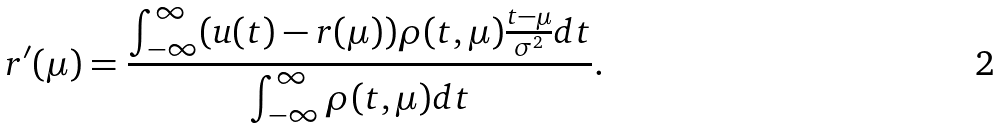<formula> <loc_0><loc_0><loc_500><loc_500>r ^ { \prime } ( \mu ) = \frac { \int _ { - \infty } ^ { \infty } ( u ( t ) - r ( \mu ) ) \rho ( t , \mu ) \frac { t - \mu } { \sigma ^ { 2 } } d t } { \int _ { - \infty } ^ { \infty } \rho ( t , \mu ) d t } .</formula> 